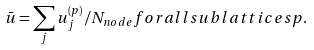Convert formula to latex. <formula><loc_0><loc_0><loc_500><loc_500>\bar { u } = \sum _ { j } { u } ^ { ( p ) } _ { j } / N _ { n o d e } { f o r a l l s u b l a t t i c e s } p .</formula> 